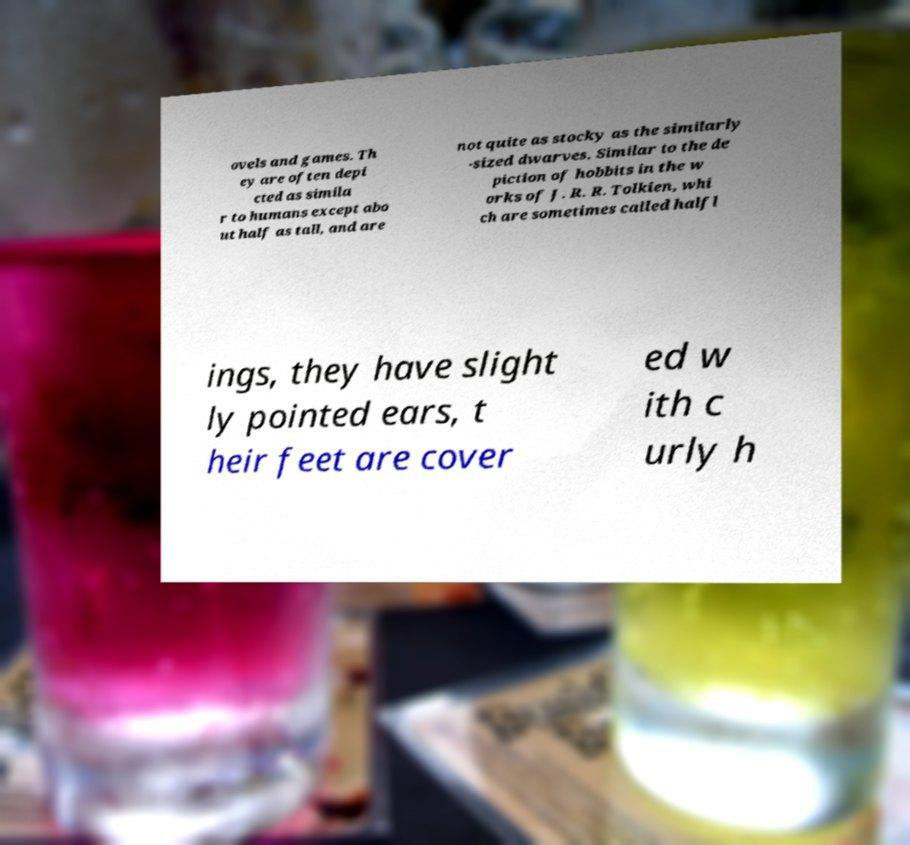There's text embedded in this image that I need extracted. Can you transcribe it verbatim? ovels and games. Th ey are often depi cted as simila r to humans except abo ut half as tall, and are not quite as stocky as the similarly -sized dwarves. Similar to the de piction of hobbits in the w orks of J. R. R. Tolkien, whi ch are sometimes called halfl ings, they have slight ly pointed ears, t heir feet are cover ed w ith c urly h 